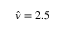Convert formula to latex. <formula><loc_0><loc_0><loc_500><loc_500>\hat { \nu } = 2 . 5</formula> 